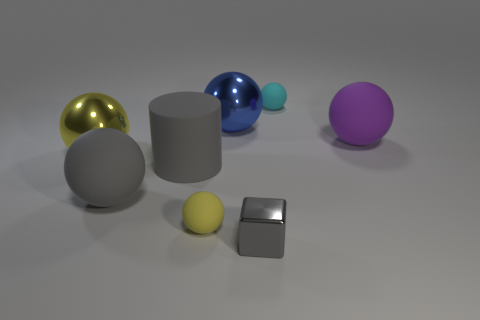Do the cube and the cylinder have the same color?
Ensure brevity in your answer.  Yes. Are there any other things that are the same shape as the small gray metallic thing?
Keep it short and to the point. No. Is there a small cyan rubber thing behind the tiny matte thing that is in front of the large gray thing behind the gray sphere?
Offer a terse response. Yes. What number of big things are either purple rubber things or blue rubber objects?
Give a very brief answer. 1. What is the color of the cylinder that is the same size as the gray matte sphere?
Your answer should be compact. Gray. How many small rubber balls are in front of the cyan matte thing?
Keep it short and to the point. 1. Is there a small cylinder made of the same material as the big gray sphere?
Your answer should be very brief. No. There is a big rubber object that is the same color as the matte cylinder; what shape is it?
Offer a very short reply. Sphere. The tiny object that is behind the yellow matte sphere is what color?
Ensure brevity in your answer.  Cyan. Is the number of big purple balls on the right side of the blue metal sphere the same as the number of large gray rubber things in front of the big cylinder?
Your answer should be compact. Yes. 